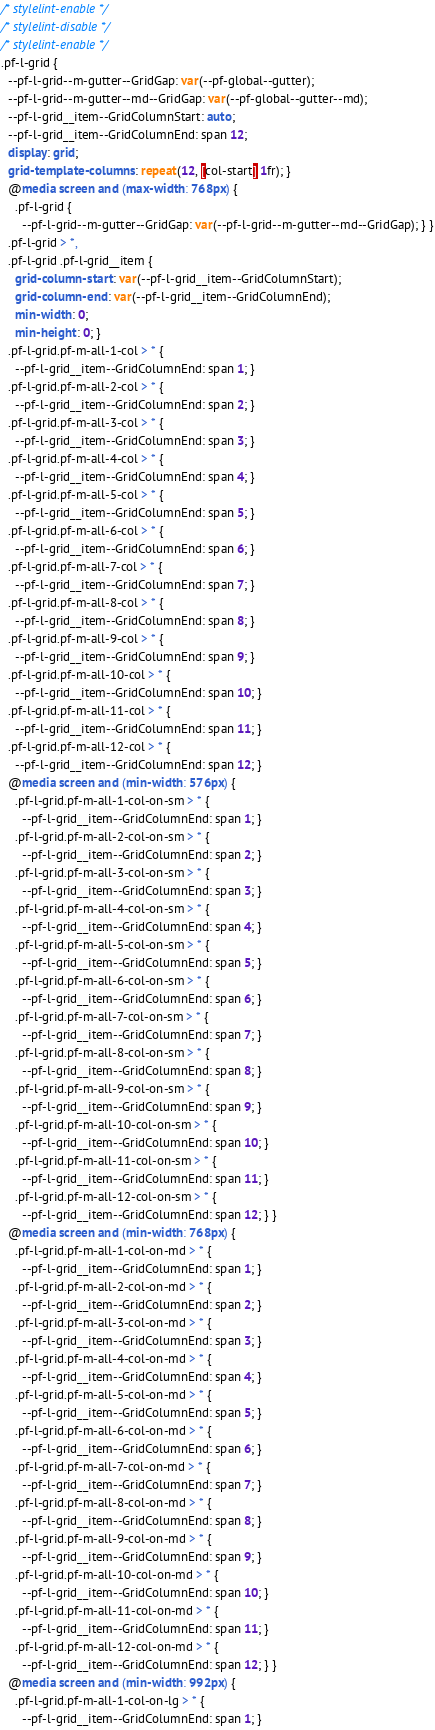Convert code to text. <code><loc_0><loc_0><loc_500><loc_500><_CSS_>/* stylelint-enable */
/* stylelint-disable */
/* stylelint-enable */
.pf-l-grid {
  --pf-l-grid--m-gutter--GridGap: var(--pf-global--gutter);
  --pf-l-grid--m-gutter--md--GridGap: var(--pf-global--gutter--md);
  --pf-l-grid__item--GridColumnStart: auto;
  --pf-l-grid__item--GridColumnEnd: span 12;
  display: grid;
  grid-template-columns: repeat(12, [col-start] 1fr); }
  @media screen and (max-width: 768px) {
    .pf-l-grid {
      --pf-l-grid--m-gutter--GridGap: var(--pf-l-grid--m-gutter--md--GridGap); } }
  .pf-l-grid > *,
  .pf-l-grid .pf-l-grid__item {
    grid-column-start: var(--pf-l-grid__item--GridColumnStart);
    grid-column-end: var(--pf-l-grid__item--GridColumnEnd);
    min-width: 0;
    min-height: 0; }
  .pf-l-grid.pf-m-all-1-col > * {
    --pf-l-grid__item--GridColumnEnd: span 1; }
  .pf-l-grid.pf-m-all-2-col > * {
    --pf-l-grid__item--GridColumnEnd: span 2; }
  .pf-l-grid.pf-m-all-3-col > * {
    --pf-l-grid__item--GridColumnEnd: span 3; }
  .pf-l-grid.pf-m-all-4-col > * {
    --pf-l-grid__item--GridColumnEnd: span 4; }
  .pf-l-grid.pf-m-all-5-col > * {
    --pf-l-grid__item--GridColumnEnd: span 5; }
  .pf-l-grid.pf-m-all-6-col > * {
    --pf-l-grid__item--GridColumnEnd: span 6; }
  .pf-l-grid.pf-m-all-7-col > * {
    --pf-l-grid__item--GridColumnEnd: span 7; }
  .pf-l-grid.pf-m-all-8-col > * {
    --pf-l-grid__item--GridColumnEnd: span 8; }
  .pf-l-grid.pf-m-all-9-col > * {
    --pf-l-grid__item--GridColumnEnd: span 9; }
  .pf-l-grid.pf-m-all-10-col > * {
    --pf-l-grid__item--GridColumnEnd: span 10; }
  .pf-l-grid.pf-m-all-11-col > * {
    --pf-l-grid__item--GridColumnEnd: span 11; }
  .pf-l-grid.pf-m-all-12-col > * {
    --pf-l-grid__item--GridColumnEnd: span 12; }
  @media screen and (min-width: 576px) {
    .pf-l-grid.pf-m-all-1-col-on-sm > * {
      --pf-l-grid__item--GridColumnEnd: span 1; }
    .pf-l-grid.pf-m-all-2-col-on-sm > * {
      --pf-l-grid__item--GridColumnEnd: span 2; }
    .pf-l-grid.pf-m-all-3-col-on-sm > * {
      --pf-l-grid__item--GridColumnEnd: span 3; }
    .pf-l-grid.pf-m-all-4-col-on-sm > * {
      --pf-l-grid__item--GridColumnEnd: span 4; }
    .pf-l-grid.pf-m-all-5-col-on-sm > * {
      --pf-l-grid__item--GridColumnEnd: span 5; }
    .pf-l-grid.pf-m-all-6-col-on-sm > * {
      --pf-l-grid__item--GridColumnEnd: span 6; }
    .pf-l-grid.pf-m-all-7-col-on-sm > * {
      --pf-l-grid__item--GridColumnEnd: span 7; }
    .pf-l-grid.pf-m-all-8-col-on-sm > * {
      --pf-l-grid__item--GridColumnEnd: span 8; }
    .pf-l-grid.pf-m-all-9-col-on-sm > * {
      --pf-l-grid__item--GridColumnEnd: span 9; }
    .pf-l-grid.pf-m-all-10-col-on-sm > * {
      --pf-l-grid__item--GridColumnEnd: span 10; }
    .pf-l-grid.pf-m-all-11-col-on-sm > * {
      --pf-l-grid__item--GridColumnEnd: span 11; }
    .pf-l-grid.pf-m-all-12-col-on-sm > * {
      --pf-l-grid__item--GridColumnEnd: span 12; } }
  @media screen and (min-width: 768px) {
    .pf-l-grid.pf-m-all-1-col-on-md > * {
      --pf-l-grid__item--GridColumnEnd: span 1; }
    .pf-l-grid.pf-m-all-2-col-on-md > * {
      --pf-l-grid__item--GridColumnEnd: span 2; }
    .pf-l-grid.pf-m-all-3-col-on-md > * {
      --pf-l-grid__item--GridColumnEnd: span 3; }
    .pf-l-grid.pf-m-all-4-col-on-md > * {
      --pf-l-grid__item--GridColumnEnd: span 4; }
    .pf-l-grid.pf-m-all-5-col-on-md > * {
      --pf-l-grid__item--GridColumnEnd: span 5; }
    .pf-l-grid.pf-m-all-6-col-on-md > * {
      --pf-l-grid__item--GridColumnEnd: span 6; }
    .pf-l-grid.pf-m-all-7-col-on-md > * {
      --pf-l-grid__item--GridColumnEnd: span 7; }
    .pf-l-grid.pf-m-all-8-col-on-md > * {
      --pf-l-grid__item--GridColumnEnd: span 8; }
    .pf-l-grid.pf-m-all-9-col-on-md > * {
      --pf-l-grid__item--GridColumnEnd: span 9; }
    .pf-l-grid.pf-m-all-10-col-on-md > * {
      --pf-l-grid__item--GridColumnEnd: span 10; }
    .pf-l-grid.pf-m-all-11-col-on-md > * {
      --pf-l-grid__item--GridColumnEnd: span 11; }
    .pf-l-grid.pf-m-all-12-col-on-md > * {
      --pf-l-grid__item--GridColumnEnd: span 12; } }
  @media screen and (min-width: 992px) {
    .pf-l-grid.pf-m-all-1-col-on-lg > * {
      --pf-l-grid__item--GridColumnEnd: span 1; }</code> 